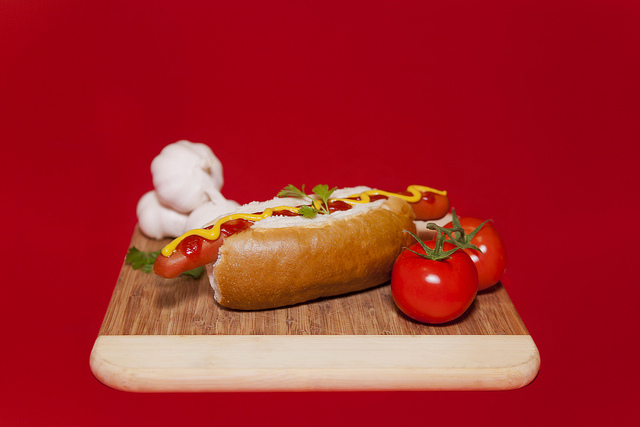Can you describe the setting in which this meal is being served? Certainly! The hot dog is prominently displayed on a cutting board, with a vibrant red background adding a pop of color. Surrounding the hot dog are ripe tomatoes with a sprig of green, their freshness enhancing the dish. A clove of garlic also sits aside, potentially hinting at a savory flavor profile for the meal. The overall setting is simple yet visually appealing, drawing attention directly to the meal. What could this meal signify in different cultures? In many Western cultures, a hot dog is a classic symbol of casual, easy-to-prepare food, often associated with outdoor events like barbecues, sporting events, or family gatherings. In others, it might signify an adaptation of international cuisine, where local ingredients are combined to create something familiar yet unique. For example, the use of fresh tomatoes and garlic could hint at a Mediterranean influence, while the clear focus on simplicity appeals to broader tastes. Imagine this hot dog being prepared in a fantasy world. What would it look like and what ingredients would it use? In a fantasy world, this hot dog might be crafted with a plump, magical sausage made from an enchanted beast, providing not only nourishment but also a hint of mystical energy. The bun could be a golden, fluffy creation from celestial grains harvested under the light of a full moon. Instead of mustard and ketchup, the condiments might include a dragon's breath hot sauce and elven berry nectar, each adding unique, otherworldly flavors. The garnish could be a shimmering alien herb that adds both an ethereal glow and a hint of sweetness to the dish. 